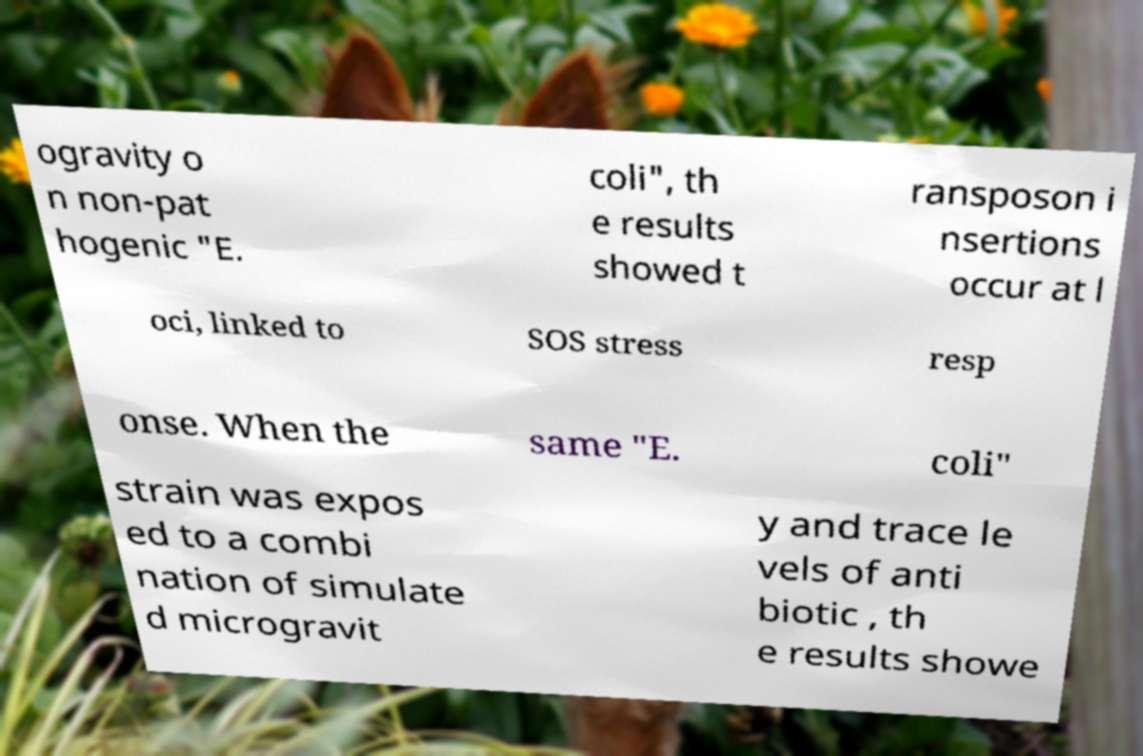Could you extract and type out the text from this image? ogravity o n non-pat hogenic "E. coli", th e results showed t ransposon i nsertions occur at l oci, linked to SOS stress resp onse. When the same "E. coli" strain was expos ed to a combi nation of simulate d microgravit y and trace le vels of anti biotic , th e results showe 